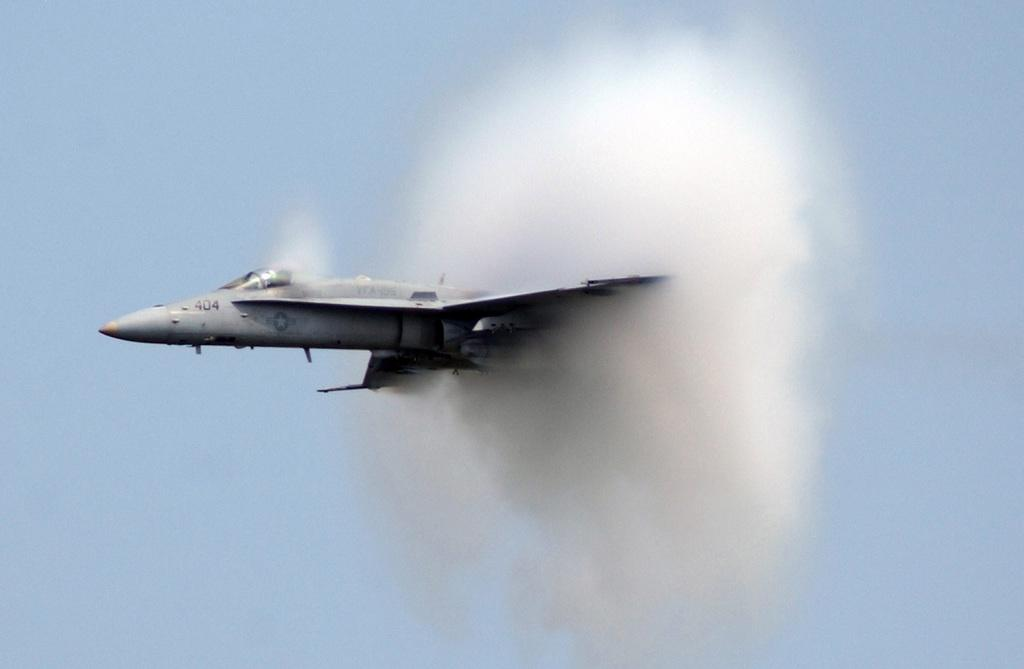<image>
Offer a succinct explanation of the picture presented. the 404 jet is flying through a cloud on an otherwise clear day 